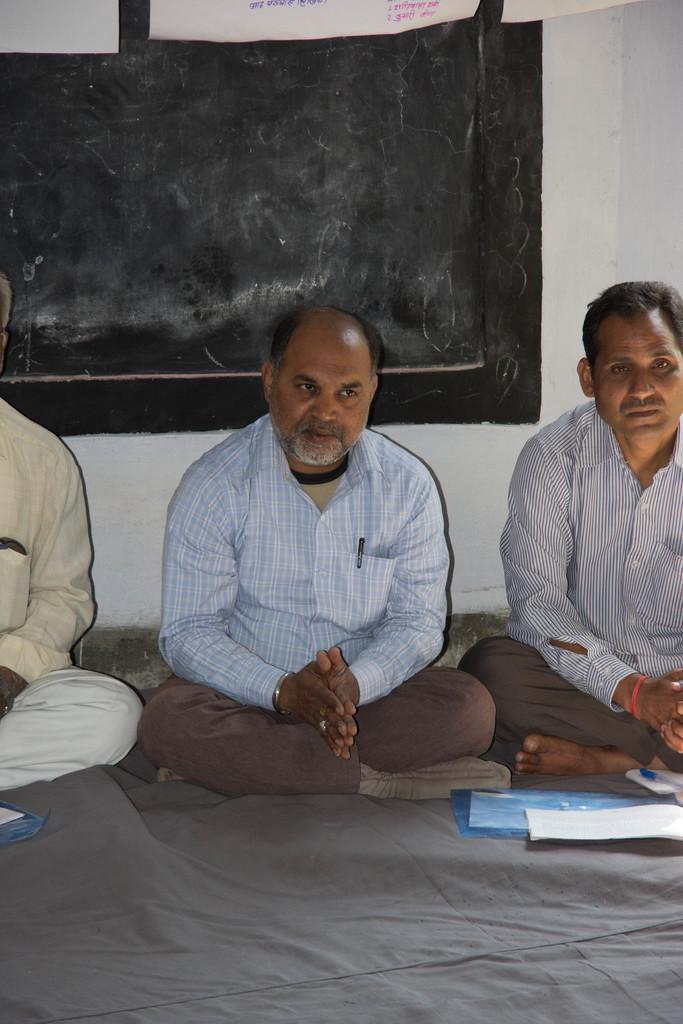Please provide a concise description of this image. In this picture, we see three men are sitting on the floor. In front of them, we see a blue color file, papers and a pen. At the bottom of the picture, we see a grey color sheet. Behind them, we see a white wall on which a blackboard is placed. At the top of the picture, we see a banner or a sheet in white color with some text written on it. 